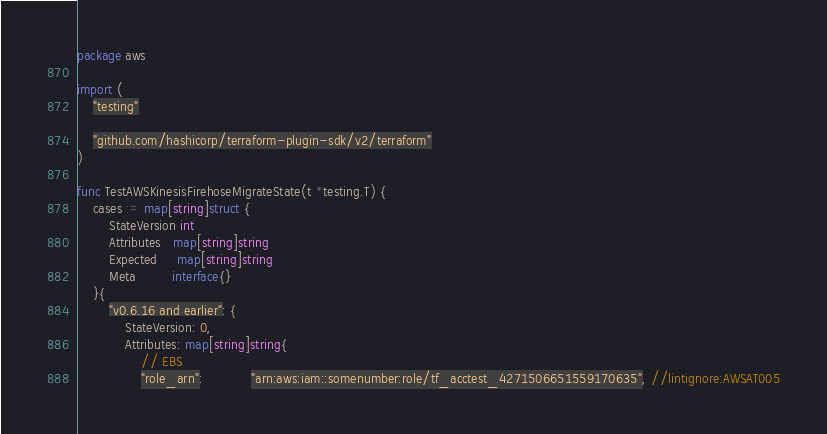<code> <loc_0><loc_0><loc_500><loc_500><_Go_>package aws

import (
	"testing"

	"github.com/hashicorp/terraform-plugin-sdk/v2/terraform"
)

func TestAWSKinesisFirehoseMigrateState(t *testing.T) {
	cases := map[string]struct {
		StateVersion int
		Attributes   map[string]string
		Expected     map[string]string
		Meta         interface{}
	}{
		"v0.6.16 and earlier": {
			StateVersion: 0,
			Attributes: map[string]string{
				// EBS
				"role_arn":            "arn:aws:iam::somenumber:role/tf_acctest_4271506651559170635", //lintignore:AWSAT005</code> 